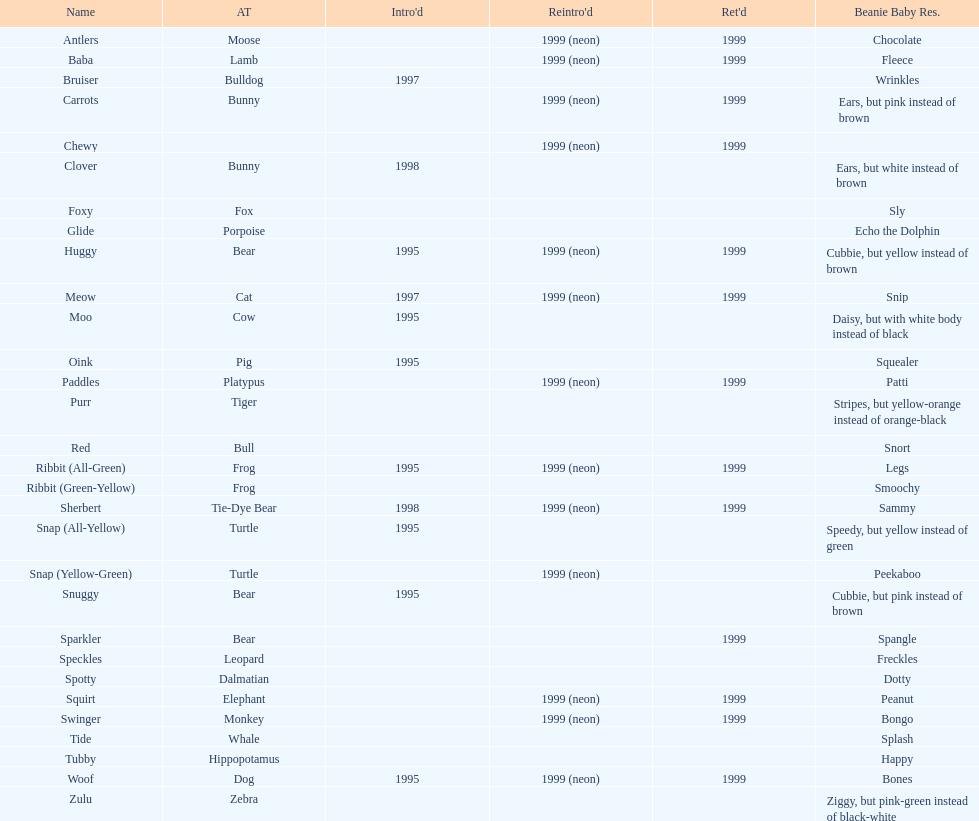Which is the only pillow pal without a listed animal type? Chewy. 